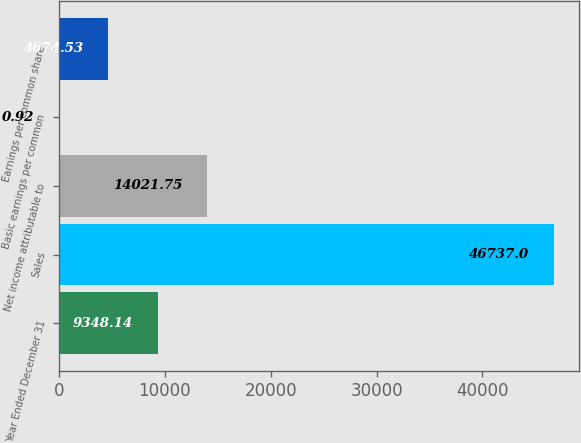Convert chart to OTSL. <chart><loc_0><loc_0><loc_500><loc_500><bar_chart><fcel>Year Ended December 31<fcel>Sales<fcel>Net income attributable to<fcel>Basic earnings per common<fcel>Earnings per common share<nl><fcel>9348.14<fcel>46737<fcel>14021.8<fcel>0.92<fcel>4674.53<nl></chart> 